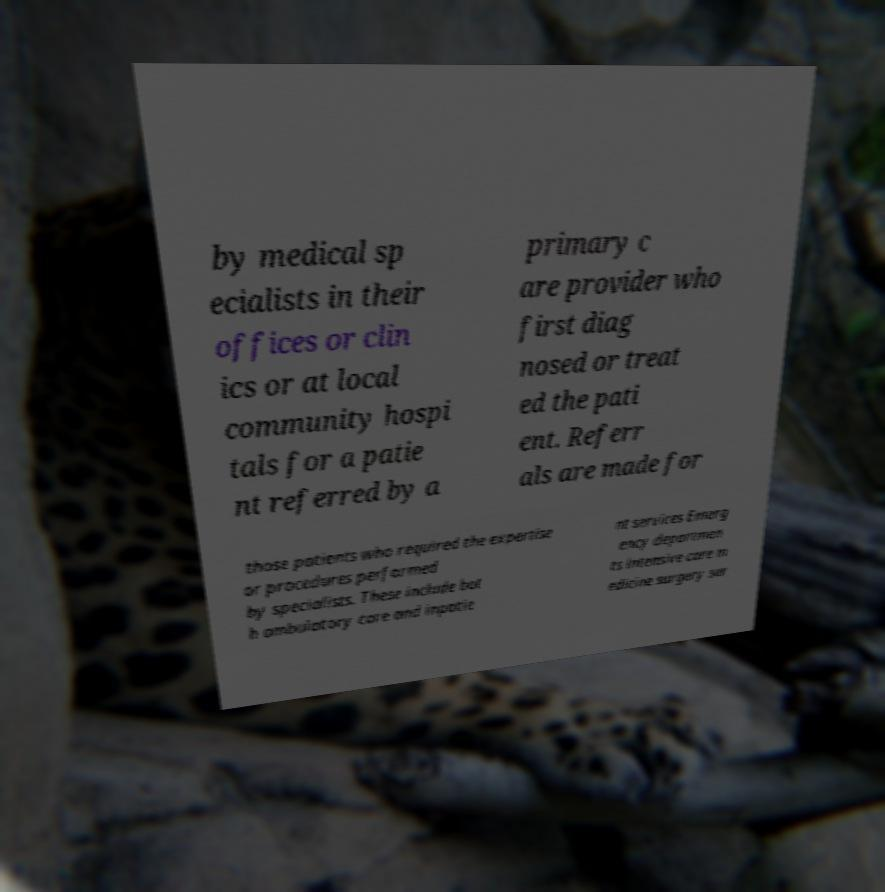Could you extract and type out the text from this image? by medical sp ecialists in their offices or clin ics or at local community hospi tals for a patie nt referred by a primary c are provider who first diag nosed or treat ed the pati ent. Referr als are made for those patients who required the expertise or procedures performed by specialists. These include bot h ambulatory care and inpatie nt services Emerg ency departmen ts intensive care m edicine surgery ser 